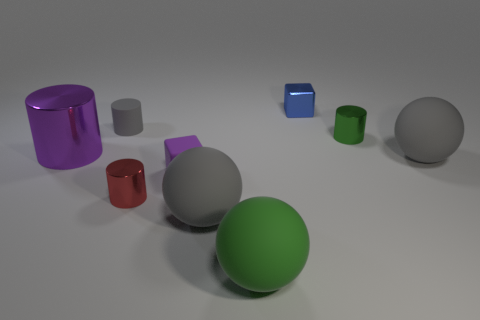Subtract all metal cylinders. How many cylinders are left? 1 Subtract all green balls. How many balls are left? 2 Subtract all cylinders. How many objects are left? 5 Subtract all cyan blocks. How many green balls are left? 1 Subtract all shiny cylinders. Subtract all tiny blue objects. How many objects are left? 5 Add 1 small purple objects. How many small purple objects are left? 2 Add 2 brown shiny balls. How many brown shiny balls exist? 2 Subtract 0 red cubes. How many objects are left? 9 Subtract 1 cylinders. How many cylinders are left? 3 Subtract all purple spheres. Subtract all gray blocks. How many spheres are left? 3 